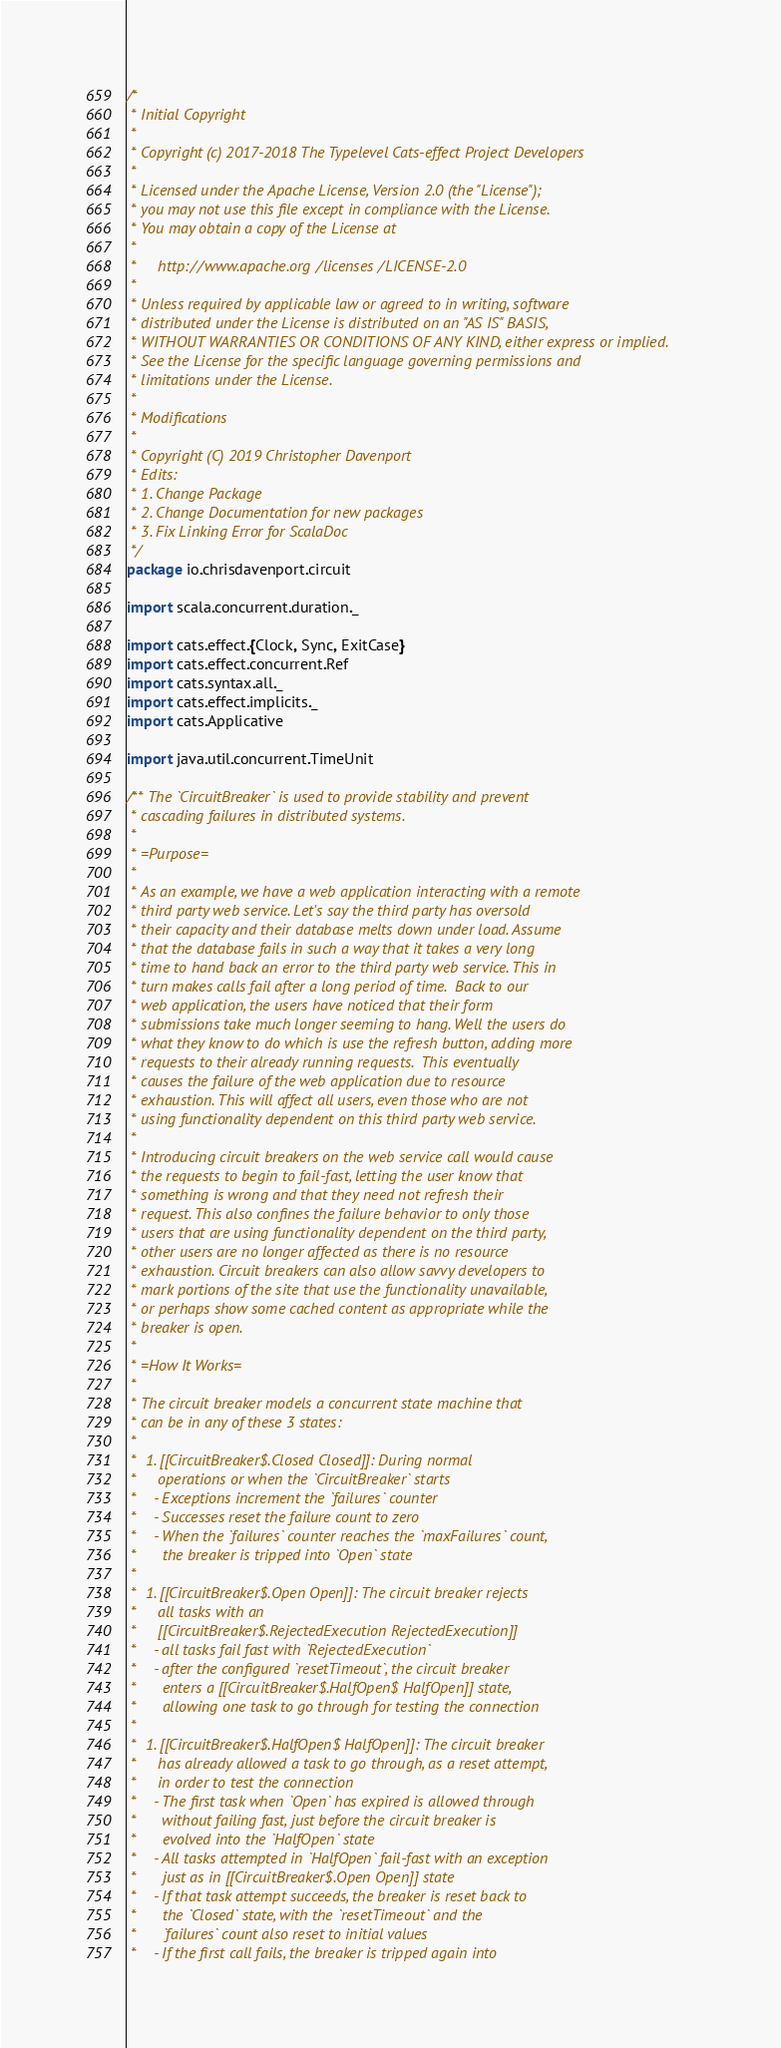Convert code to text. <code><loc_0><loc_0><loc_500><loc_500><_Scala_>/*
 * Initial Copyright
 * 
 * Copyright (c) 2017-2018 The Typelevel Cats-effect Project Developers
 *
 * Licensed under the Apache License, Version 2.0 (the "License");
 * you may not use this file except in compliance with the License.
 * You may obtain a copy of the License at
 *
 *     http://www.apache.org/licenses/LICENSE-2.0
 *
 * Unless required by applicable law or agreed to in writing, software
 * distributed under the License is distributed on an "AS IS" BASIS,
 * WITHOUT WARRANTIES OR CONDITIONS OF ANY KIND, either express or implied.
 * See the License for the specific language governing permissions and
 * limitations under the License.
 * 
 * Modifications 
 * 
 * Copyright (C) 2019 Christopher Davenport
 * Edits: 
 * 1. Change Package
 * 2. Change Documentation for new packages
 * 3. Fix Linking Error for ScalaDoc
 */
package io.chrisdavenport.circuit

import scala.concurrent.duration._

import cats.effect.{Clock, Sync, ExitCase}
import cats.effect.concurrent.Ref
import cats.syntax.all._
import cats.effect.implicits._
import cats.Applicative

import java.util.concurrent.TimeUnit

/** The `CircuitBreaker` is used to provide stability and prevent
 * cascading failures in distributed systems.
 *
 * =Purpose=
 *
 * As an example, we have a web application interacting with a remote
 * third party web service. Let's say the third party has oversold
 * their capacity and their database melts down under load. Assume
 * that the database fails in such a way that it takes a very long
 * time to hand back an error to the third party web service. This in
 * turn makes calls fail after a long period of time.  Back to our
 * web application, the users have noticed that their form
 * submissions take much longer seeming to hang. Well the users do
 * what they know to do which is use the refresh button, adding more
 * requests to their already running requests.  This eventually
 * causes the failure of the web application due to resource
 * exhaustion. This will affect all users, even those who are not
 * using functionality dependent on this third party web service.
 *
 * Introducing circuit breakers on the web service call would cause
 * the requests to begin to fail-fast, letting the user know that
 * something is wrong and that they need not refresh their
 * request. This also confines the failure behavior to only those
 * users that are using functionality dependent on the third party,
 * other users are no longer affected as there is no resource
 * exhaustion. Circuit breakers can also allow savvy developers to
 * mark portions of the site that use the functionality unavailable,
 * or perhaps show some cached content as appropriate while the
 * breaker is open.
 *
 * =How It Works=
 *
 * The circuit breaker models a concurrent state machine that
 * can be in any of these 3 states:
 *
 *  1. [[CircuitBreaker$.Closed Closed]]: During normal
 *     operations or when the `CircuitBreaker` starts
 *    - Exceptions increment the `failures` counter
 *    - Successes reset the failure count to zero
 *    - When the `failures` counter reaches the `maxFailures` count,
 *      the breaker is tripped into `Open` state
 *
 *  1. [[CircuitBreaker$.Open Open]]: The circuit breaker rejects
 *     all tasks with an
 *     [[CircuitBreaker$.RejectedExecution RejectedExecution]]
 *    - all tasks fail fast with `RejectedExecution`
 *    - after the configured `resetTimeout`, the circuit breaker
 *      enters a [[CircuitBreaker$.HalfOpen$ HalfOpen]] state,
 *      allowing one task to go through for testing the connection
 *
 *  1. [[CircuitBreaker$.HalfOpen$ HalfOpen]]: The circuit breaker
 *     has already allowed a task to go through, as a reset attempt,
 *     in order to test the connection
 *    - The first task when `Open` has expired is allowed through
 *      without failing fast, just before the circuit breaker is
 *      evolved into the `HalfOpen` state
 *    - All tasks attempted in `HalfOpen` fail-fast with an exception
 *      just as in [[CircuitBreaker$.Open Open]] state
 *    - If that task attempt succeeds, the breaker is reset back to
 *      the `Closed` state, with the `resetTimeout` and the
 *      `failures` count also reset to initial values
 *    - If the first call fails, the breaker is tripped again into</code> 